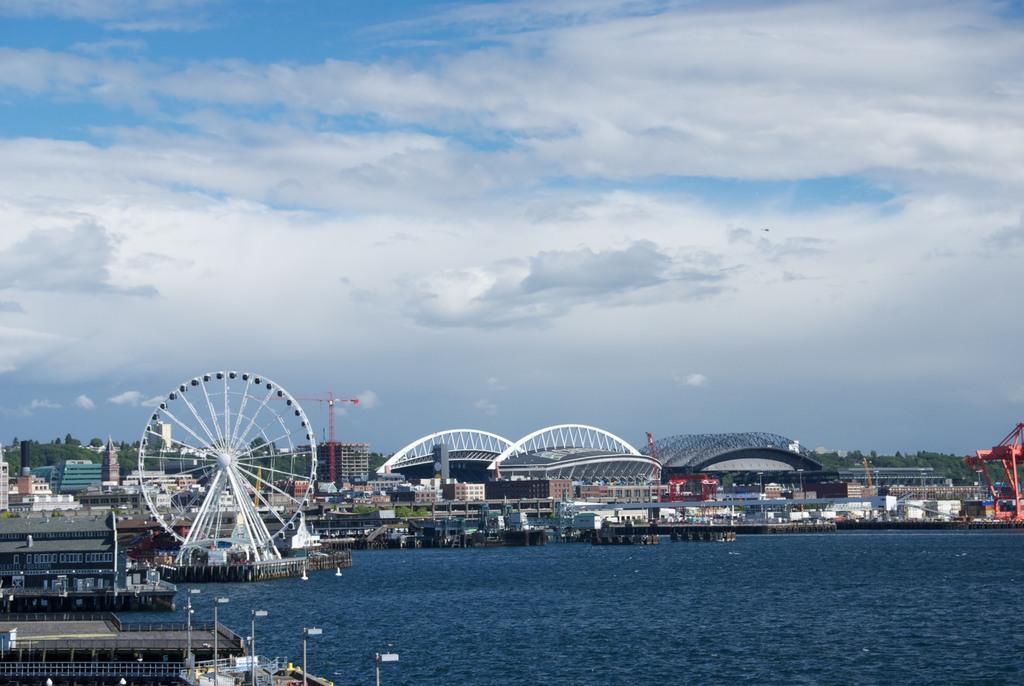How would you summarize this image in a sentence or two? In the foreground of the image we can see a lake. In the background we can see a Ferris wheel , buildings, group of trees and the cloudy sky. 